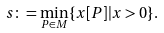Convert formula to latex. <formula><loc_0><loc_0><loc_500><loc_500>s \colon = \min _ { P \in M } \{ x [ P ] | x > 0 \} .</formula> 